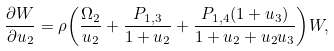Convert formula to latex. <formula><loc_0><loc_0><loc_500><loc_500>\frac { { \partial } W } { { \partial } u _ { 2 } } = \rho { \left ( \frac { \Omega _ { 2 } } { u _ { 2 } } + \frac { P _ { 1 , 3 } } { 1 + u _ { 2 } } + \frac { P _ { 1 , 4 } ( 1 + u _ { 3 } ) } { 1 + u _ { 2 } + u _ { 2 } u _ { 3 } } \right ) } W ,</formula> 